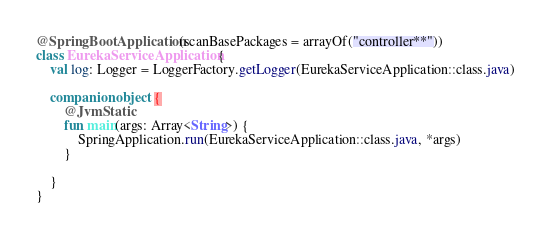Convert code to text. <code><loc_0><loc_0><loc_500><loc_500><_Kotlin_>@SpringBootApplication(scanBasePackages = arrayOf("controller**"))
class EurekaServiceApplication {
    val log: Logger = LoggerFactory.getLogger(EurekaServiceApplication::class.java)

    companion object {
        @JvmStatic
        fun main(args: Array<String>) {
            SpringApplication.run(EurekaServiceApplication::class.java, *args)
        }

    }
}</code> 